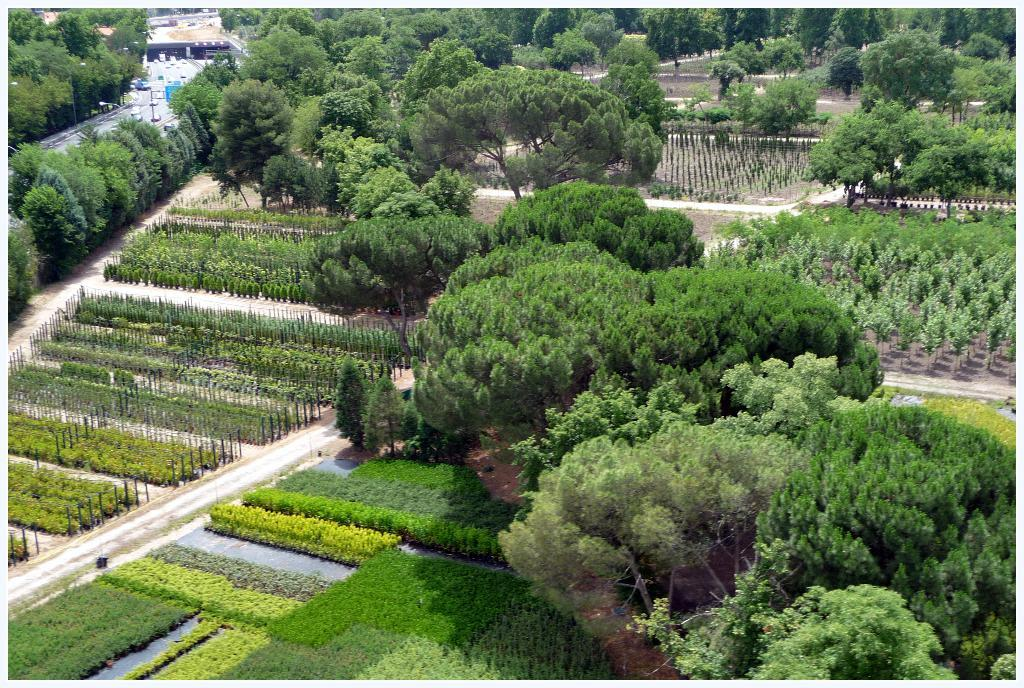What type of vegetation can be seen in the image? There are many trees and small plants in the image. Where is the road located in the image? The road is at the left side of the image. What type of mass can be seen affecting the trees in the image? There is no mass or effect visible on the trees in the image; they appear to be standing normally. Is there a porter carrying luggage in the image? There is no porter or luggage present in the image. 